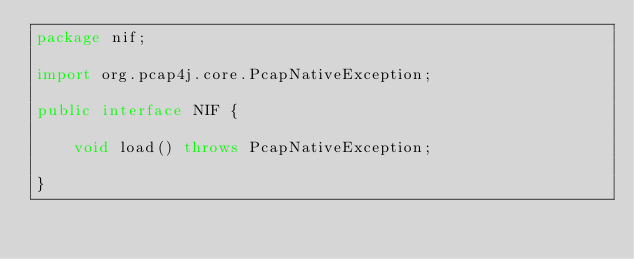Convert code to text. <code><loc_0><loc_0><loc_500><loc_500><_Java_>package nif;

import org.pcap4j.core.PcapNativeException;

public interface NIF {

    void load() throws PcapNativeException;

}
</code> 